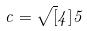Convert formula to latex. <formula><loc_0><loc_0><loc_500><loc_500>c = \sqrt { [ } 4 ] { 5 }</formula> 